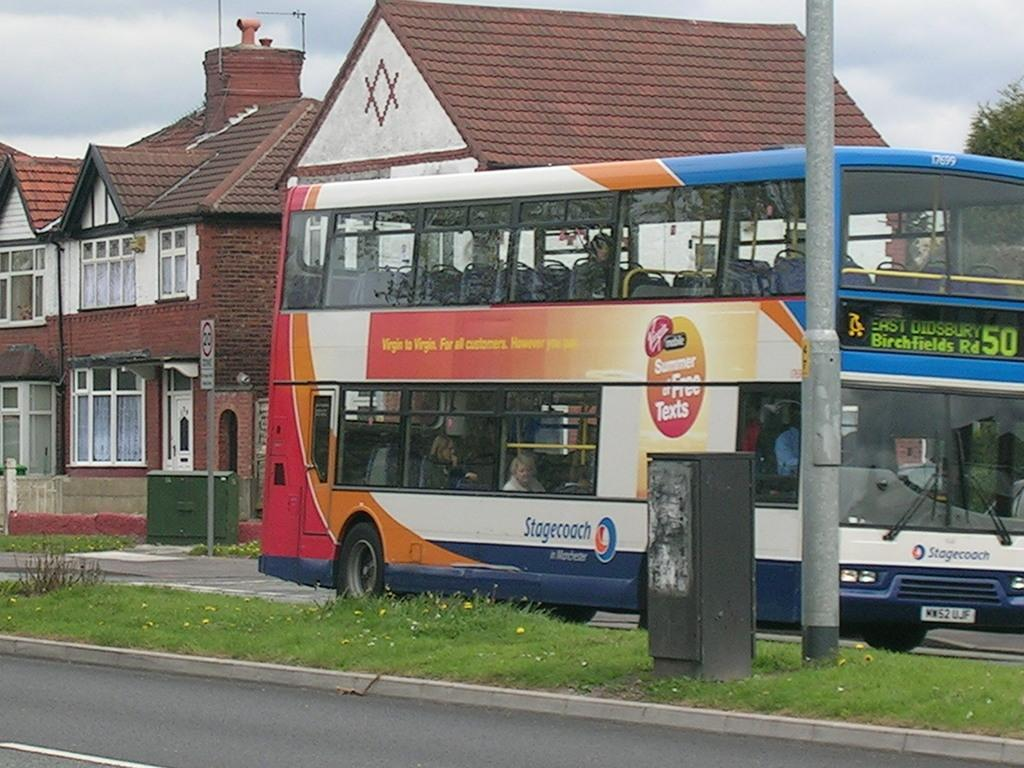<image>
Give a short and clear explanation of the subsequent image. Stagecoach bus with the number 50 on the front. 